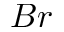Convert formula to latex. <formula><loc_0><loc_0><loc_500><loc_500>B r</formula> 